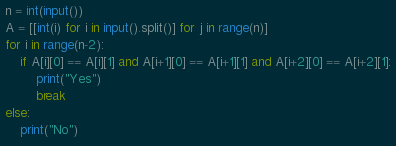<code> <loc_0><loc_0><loc_500><loc_500><_Python_>n = int(input())
A = [[int(i) for i in input().split()] for j in range(n)]
for i in range(n-2):
    if A[i][0] == A[i][1] and A[i+1][0] == A[i+1][1] and A[i+2][0] == A[i+2][1]:
        print("Yes")
        break
else:
    print("No")
</code> 